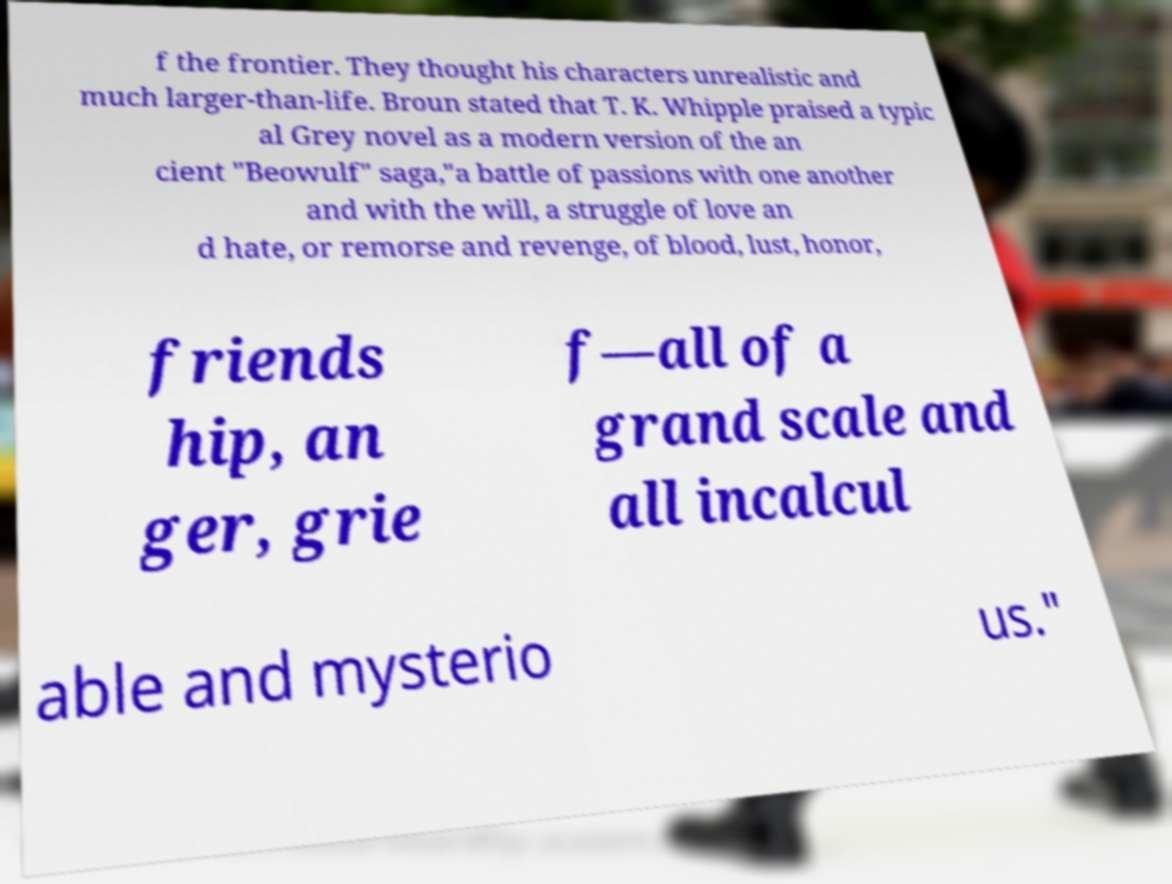I need the written content from this picture converted into text. Can you do that? f the frontier. They thought his characters unrealistic and much larger-than-life. Broun stated that T. K. Whipple praised a typic al Grey novel as a modern version of the an cient "Beowulf" saga,"a battle of passions with one another and with the will, a struggle of love an d hate, or remorse and revenge, of blood, lust, honor, friends hip, an ger, grie f—all of a grand scale and all incalcul able and mysterio us." 